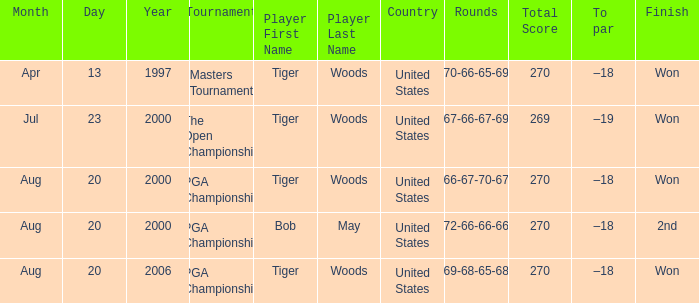What is the worst (highest) score? 270.0. 